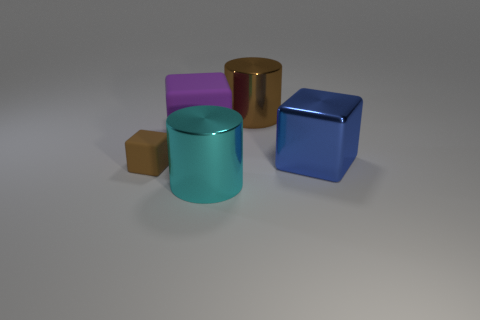Is there any indication of the size of these objects in the image? The image does not provide any clear reference points for scale, such as familiar objects or patterns. Therefore, it's difficult to determine the exact size of the objects without additional context. 